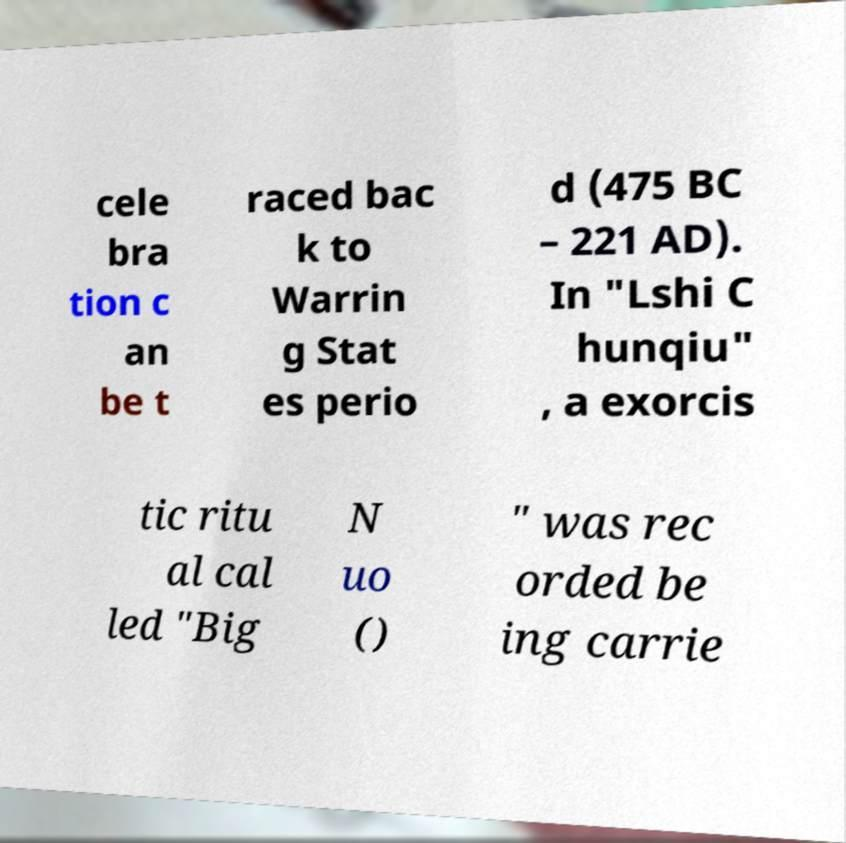Please read and relay the text visible in this image. What does it say? cele bra tion c an be t raced bac k to Warrin g Stat es perio d (475 BC – 221 AD). In "Lshi C hunqiu" , a exorcis tic ritu al cal led "Big N uo () " was rec orded be ing carrie 